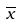<formula> <loc_0><loc_0><loc_500><loc_500>\overline { x }</formula> 